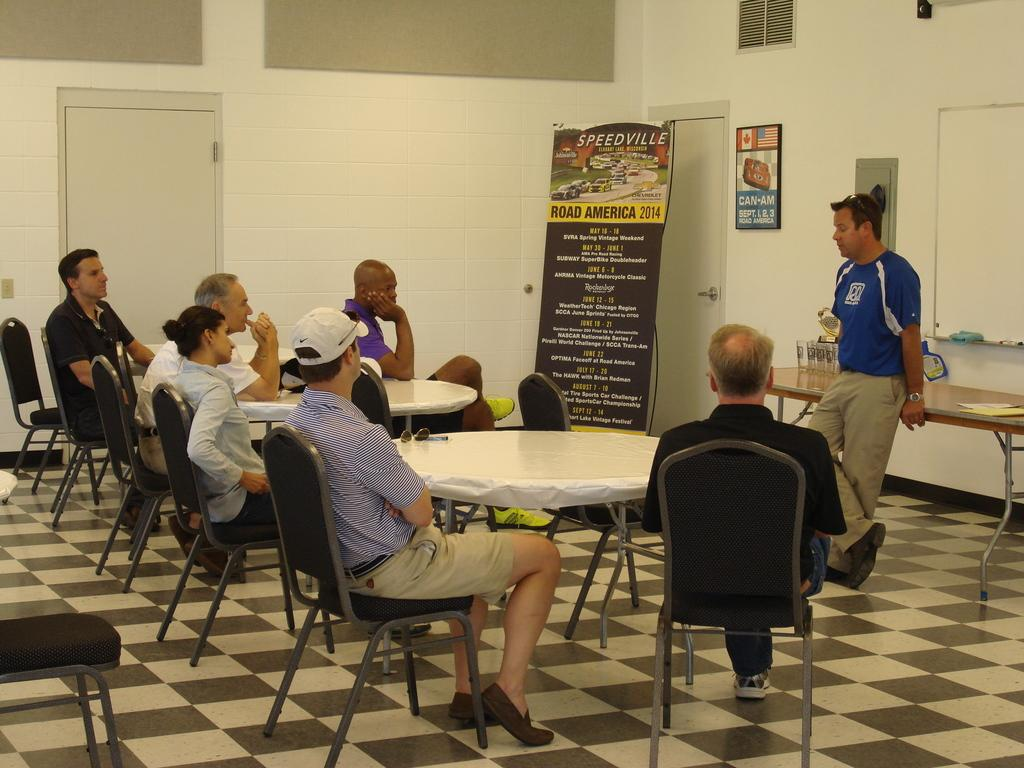What are the people in the image doing? People are sitting on chairs in the image. What objects are in front of the sitting people? Tables are present in front of the sitting people. Can you describe the person standing at the right side? There is a person standing at the right side in the image. What is written on the banner at the back of the scene? The banner has "Road America 2014" written on it. What type of popcorn is being served at the event in the image? There is no popcorn present in the image, so it cannot be determined what type of popcorn might be served. Can you see a star in the image? There is no star visible in the image. 